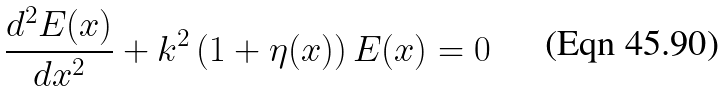<formula> <loc_0><loc_0><loc_500><loc_500>\frac { d ^ { 2 } E ( x ) } { d x ^ { 2 } } + k ^ { 2 } \left ( 1 + \eta ( x ) \right ) E ( x ) = 0</formula> 